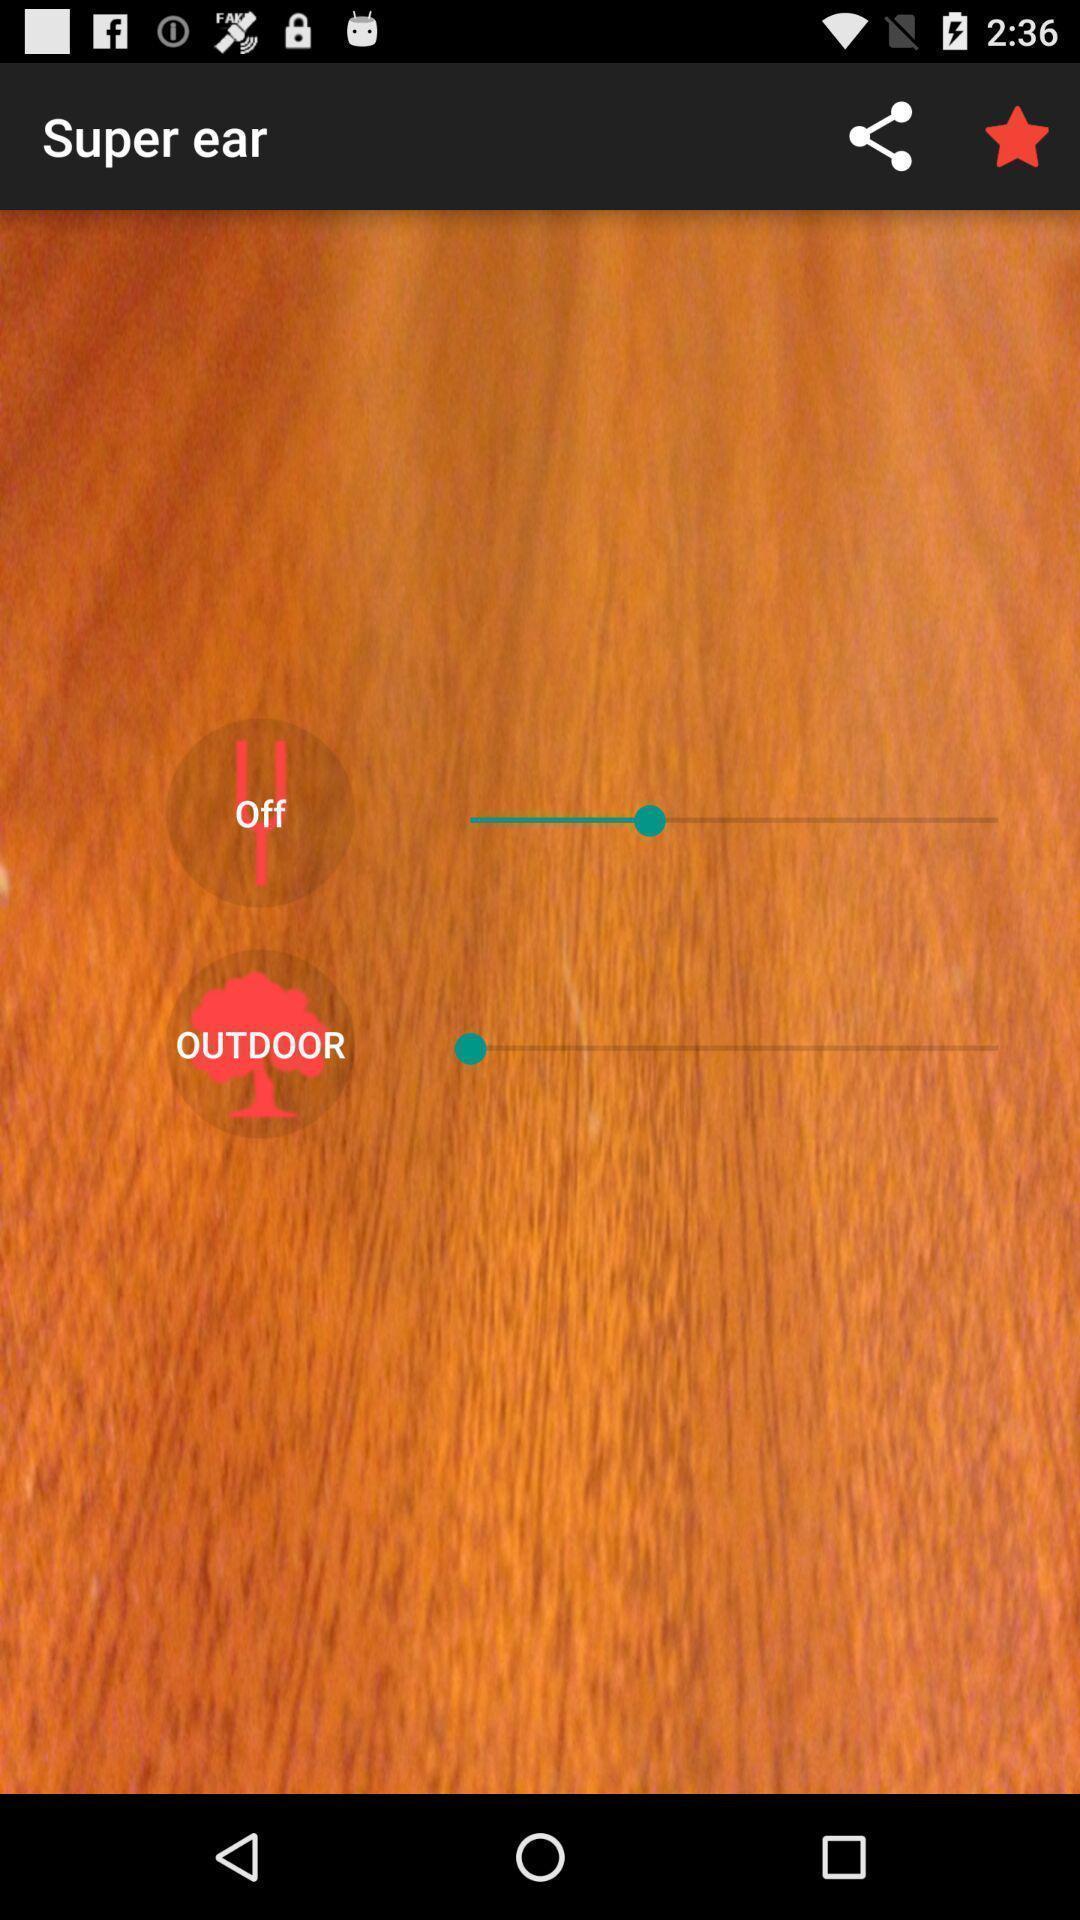Explain the elements present in this screenshot. Volume control bars are showing. 